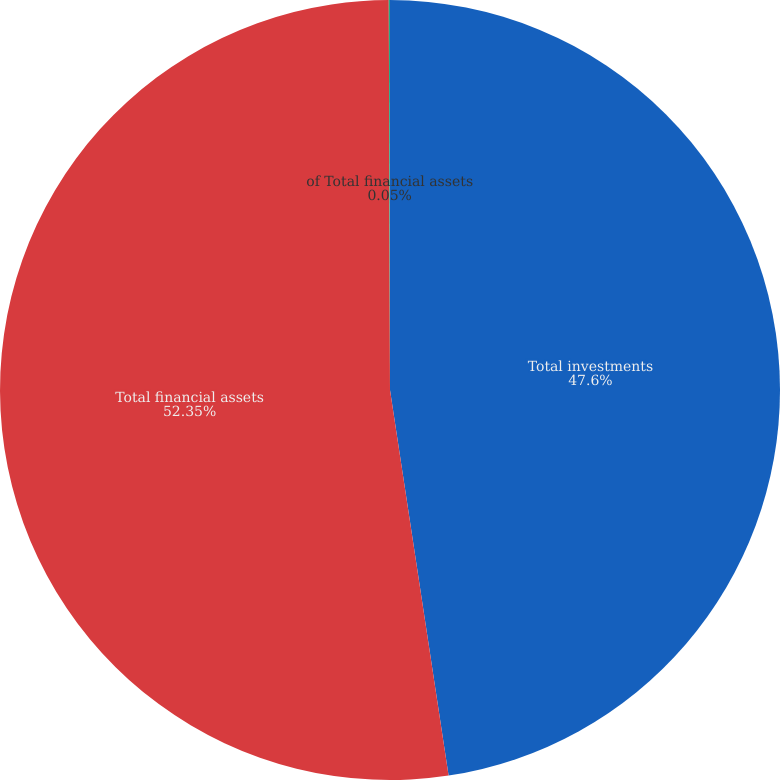Convert chart to OTSL. <chart><loc_0><loc_0><loc_500><loc_500><pie_chart><fcel>Total investments<fcel>Total financial assets<fcel>of Total financial assets<nl><fcel>47.6%<fcel>52.35%<fcel>0.05%<nl></chart> 